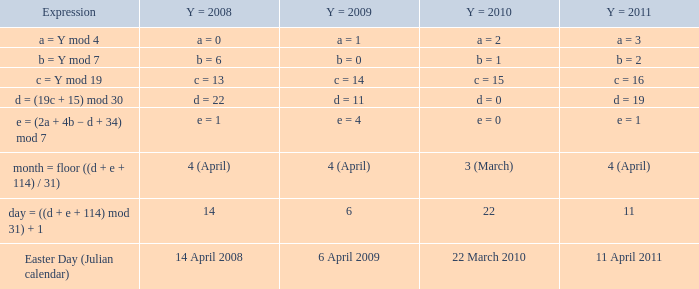What is  the y = 2009 when the expression is month = floor ((d + e + 114) / 31)? 4 (April). 